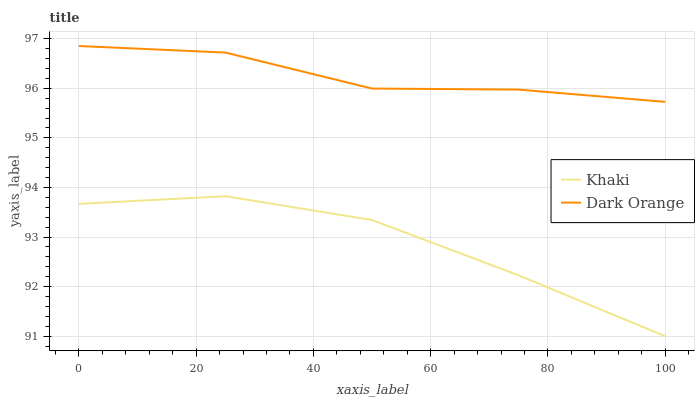Does Khaki have the minimum area under the curve?
Answer yes or no. Yes. Does Dark Orange have the maximum area under the curve?
Answer yes or no. Yes. Does Khaki have the maximum area under the curve?
Answer yes or no. No. Is Khaki the smoothest?
Answer yes or no. Yes. Is Dark Orange the roughest?
Answer yes or no. Yes. Is Khaki the roughest?
Answer yes or no. No. Does Khaki have the lowest value?
Answer yes or no. Yes. Does Dark Orange have the highest value?
Answer yes or no. Yes. Does Khaki have the highest value?
Answer yes or no. No. Is Khaki less than Dark Orange?
Answer yes or no. Yes. Is Dark Orange greater than Khaki?
Answer yes or no. Yes. Does Khaki intersect Dark Orange?
Answer yes or no. No. 